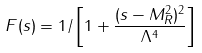Convert formula to latex. <formula><loc_0><loc_0><loc_500><loc_500>F ( s ) = 1 / \left [ 1 + \frac { ( s - M _ { R } ^ { 2 } ) ^ { 2 } } { \Lambda ^ { 4 } } \right ]</formula> 